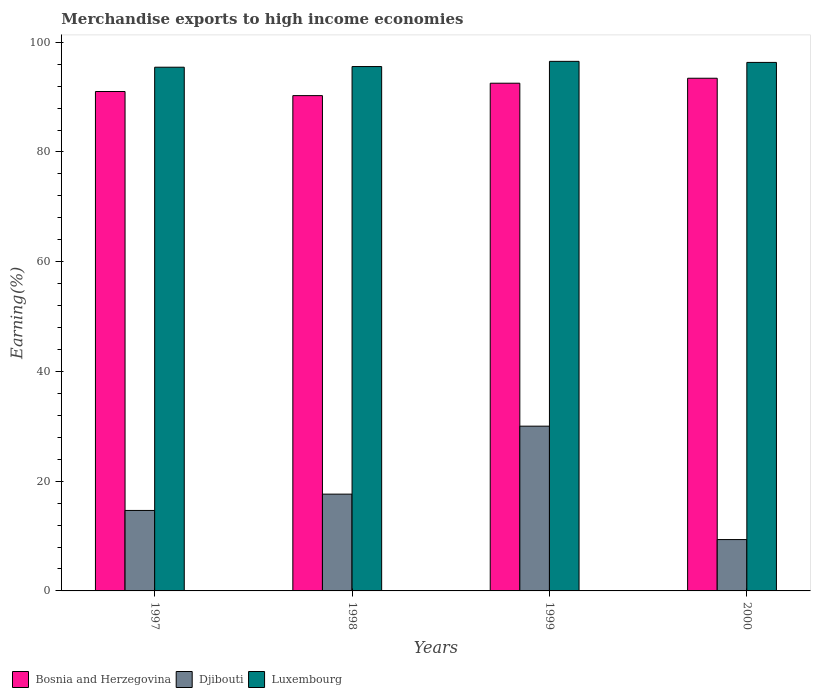How many different coloured bars are there?
Provide a short and direct response. 3. How many groups of bars are there?
Your answer should be very brief. 4. How many bars are there on the 3rd tick from the right?
Provide a succinct answer. 3. What is the label of the 3rd group of bars from the left?
Provide a short and direct response. 1999. What is the percentage of amount earned from merchandise exports in Bosnia and Herzegovina in 2000?
Keep it short and to the point. 93.43. Across all years, what is the maximum percentage of amount earned from merchandise exports in Djibouti?
Provide a succinct answer. 30.03. Across all years, what is the minimum percentage of amount earned from merchandise exports in Bosnia and Herzegovina?
Your response must be concise. 90.27. In which year was the percentage of amount earned from merchandise exports in Bosnia and Herzegovina minimum?
Keep it short and to the point. 1998. What is the total percentage of amount earned from merchandise exports in Bosnia and Herzegovina in the graph?
Ensure brevity in your answer.  367.25. What is the difference between the percentage of amount earned from merchandise exports in Bosnia and Herzegovina in 1999 and that in 2000?
Provide a succinct answer. -0.9. What is the difference between the percentage of amount earned from merchandise exports in Bosnia and Herzegovina in 1998 and the percentage of amount earned from merchandise exports in Luxembourg in 1999?
Keep it short and to the point. -6.25. What is the average percentage of amount earned from merchandise exports in Luxembourg per year?
Keep it short and to the point. 95.96. In the year 1998, what is the difference between the percentage of amount earned from merchandise exports in Bosnia and Herzegovina and percentage of amount earned from merchandise exports in Djibouti?
Your response must be concise. 72.63. In how many years, is the percentage of amount earned from merchandise exports in Bosnia and Herzegovina greater than 84 %?
Offer a very short reply. 4. What is the ratio of the percentage of amount earned from merchandise exports in Luxembourg in 1997 to that in 1998?
Your response must be concise. 1. What is the difference between the highest and the second highest percentage of amount earned from merchandise exports in Djibouti?
Your answer should be compact. 12.39. What is the difference between the highest and the lowest percentage of amount earned from merchandise exports in Luxembourg?
Make the answer very short. 1.07. What does the 1st bar from the left in 2000 represents?
Offer a very short reply. Bosnia and Herzegovina. What does the 1st bar from the right in 2000 represents?
Your answer should be very brief. Luxembourg. Are all the bars in the graph horizontal?
Ensure brevity in your answer.  No. Are the values on the major ticks of Y-axis written in scientific E-notation?
Provide a succinct answer. No. How many legend labels are there?
Your response must be concise. 3. How are the legend labels stacked?
Your response must be concise. Horizontal. What is the title of the graph?
Make the answer very short. Merchandise exports to high income economies. What is the label or title of the X-axis?
Give a very brief answer. Years. What is the label or title of the Y-axis?
Provide a short and direct response. Earning(%). What is the Earning(%) in Bosnia and Herzegovina in 1997?
Offer a very short reply. 91.02. What is the Earning(%) in Djibouti in 1997?
Give a very brief answer. 14.67. What is the Earning(%) in Luxembourg in 1997?
Give a very brief answer. 95.44. What is the Earning(%) in Bosnia and Herzegovina in 1998?
Provide a short and direct response. 90.27. What is the Earning(%) of Djibouti in 1998?
Your answer should be compact. 17.64. What is the Earning(%) of Luxembourg in 1998?
Keep it short and to the point. 95.57. What is the Earning(%) of Bosnia and Herzegovina in 1999?
Your response must be concise. 92.53. What is the Earning(%) of Djibouti in 1999?
Keep it short and to the point. 30.03. What is the Earning(%) in Luxembourg in 1999?
Your answer should be compact. 96.51. What is the Earning(%) of Bosnia and Herzegovina in 2000?
Offer a terse response. 93.43. What is the Earning(%) of Djibouti in 2000?
Provide a succinct answer. 9.36. What is the Earning(%) of Luxembourg in 2000?
Provide a short and direct response. 96.32. Across all years, what is the maximum Earning(%) in Bosnia and Herzegovina?
Your answer should be compact. 93.43. Across all years, what is the maximum Earning(%) in Djibouti?
Offer a very short reply. 30.03. Across all years, what is the maximum Earning(%) of Luxembourg?
Your answer should be compact. 96.51. Across all years, what is the minimum Earning(%) in Bosnia and Herzegovina?
Make the answer very short. 90.27. Across all years, what is the minimum Earning(%) in Djibouti?
Offer a terse response. 9.36. Across all years, what is the minimum Earning(%) of Luxembourg?
Ensure brevity in your answer.  95.44. What is the total Earning(%) in Bosnia and Herzegovina in the graph?
Provide a succinct answer. 367.25. What is the total Earning(%) in Djibouti in the graph?
Offer a terse response. 71.69. What is the total Earning(%) in Luxembourg in the graph?
Make the answer very short. 383.84. What is the difference between the Earning(%) of Bosnia and Herzegovina in 1997 and that in 1998?
Make the answer very short. 0.75. What is the difference between the Earning(%) of Djibouti in 1997 and that in 1998?
Provide a succinct answer. -2.97. What is the difference between the Earning(%) of Luxembourg in 1997 and that in 1998?
Ensure brevity in your answer.  -0.12. What is the difference between the Earning(%) of Bosnia and Herzegovina in 1997 and that in 1999?
Offer a terse response. -1.51. What is the difference between the Earning(%) of Djibouti in 1997 and that in 1999?
Your answer should be very brief. -15.36. What is the difference between the Earning(%) of Luxembourg in 1997 and that in 1999?
Offer a terse response. -1.07. What is the difference between the Earning(%) in Bosnia and Herzegovina in 1997 and that in 2000?
Provide a succinct answer. -2.42. What is the difference between the Earning(%) of Djibouti in 1997 and that in 2000?
Your answer should be compact. 5.31. What is the difference between the Earning(%) in Luxembourg in 1997 and that in 2000?
Your response must be concise. -0.87. What is the difference between the Earning(%) of Bosnia and Herzegovina in 1998 and that in 1999?
Provide a short and direct response. -2.26. What is the difference between the Earning(%) of Djibouti in 1998 and that in 1999?
Give a very brief answer. -12.39. What is the difference between the Earning(%) in Luxembourg in 1998 and that in 1999?
Your answer should be compact. -0.95. What is the difference between the Earning(%) of Bosnia and Herzegovina in 1998 and that in 2000?
Provide a succinct answer. -3.17. What is the difference between the Earning(%) of Djibouti in 1998 and that in 2000?
Provide a succinct answer. 8.28. What is the difference between the Earning(%) of Luxembourg in 1998 and that in 2000?
Make the answer very short. -0.75. What is the difference between the Earning(%) in Bosnia and Herzegovina in 1999 and that in 2000?
Keep it short and to the point. -0.9. What is the difference between the Earning(%) in Djibouti in 1999 and that in 2000?
Ensure brevity in your answer.  20.67. What is the difference between the Earning(%) in Luxembourg in 1999 and that in 2000?
Your answer should be very brief. 0.19. What is the difference between the Earning(%) of Bosnia and Herzegovina in 1997 and the Earning(%) of Djibouti in 1998?
Make the answer very short. 73.38. What is the difference between the Earning(%) in Bosnia and Herzegovina in 1997 and the Earning(%) in Luxembourg in 1998?
Give a very brief answer. -4.55. What is the difference between the Earning(%) of Djibouti in 1997 and the Earning(%) of Luxembourg in 1998?
Provide a short and direct response. -80.9. What is the difference between the Earning(%) in Bosnia and Herzegovina in 1997 and the Earning(%) in Djibouti in 1999?
Provide a succinct answer. 60.99. What is the difference between the Earning(%) in Bosnia and Herzegovina in 1997 and the Earning(%) in Luxembourg in 1999?
Provide a succinct answer. -5.5. What is the difference between the Earning(%) in Djibouti in 1997 and the Earning(%) in Luxembourg in 1999?
Your response must be concise. -81.85. What is the difference between the Earning(%) in Bosnia and Herzegovina in 1997 and the Earning(%) in Djibouti in 2000?
Your response must be concise. 81.66. What is the difference between the Earning(%) of Bosnia and Herzegovina in 1997 and the Earning(%) of Luxembourg in 2000?
Offer a terse response. -5.3. What is the difference between the Earning(%) in Djibouti in 1997 and the Earning(%) in Luxembourg in 2000?
Make the answer very short. -81.65. What is the difference between the Earning(%) of Bosnia and Herzegovina in 1998 and the Earning(%) of Djibouti in 1999?
Provide a short and direct response. 60.24. What is the difference between the Earning(%) of Bosnia and Herzegovina in 1998 and the Earning(%) of Luxembourg in 1999?
Your answer should be compact. -6.25. What is the difference between the Earning(%) in Djibouti in 1998 and the Earning(%) in Luxembourg in 1999?
Provide a succinct answer. -78.87. What is the difference between the Earning(%) in Bosnia and Herzegovina in 1998 and the Earning(%) in Djibouti in 2000?
Give a very brief answer. 80.91. What is the difference between the Earning(%) of Bosnia and Herzegovina in 1998 and the Earning(%) of Luxembourg in 2000?
Offer a terse response. -6.05. What is the difference between the Earning(%) of Djibouti in 1998 and the Earning(%) of Luxembourg in 2000?
Your response must be concise. -78.68. What is the difference between the Earning(%) in Bosnia and Herzegovina in 1999 and the Earning(%) in Djibouti in 2000?
Make the answer very short. 83.17. What is the difference between the Earning(%) of Bosnia and Herzegovina in 1999 and the Earning(%) of Luxembourg in 2000?
Give a very brief answer. -3.79. What is the difference between the Earning(%) of Djibouti in 1999 and the Earning(%) of Luxembourg in 2000?
Provide a succinct answer. -66.29. What is the average Earning(%) in Bosnia and Herzegovina per year?
Your response must be concise. 91.81. What is the average Earning(%) in Djibouti per year?
Your answer should be compact. 17.92. What is the average Earning(%) in Luxembourg per year?
Provide a succinct answer. 95.96. In the year 1997, what is the difference between the Earning(%) in Bosnia and Herzegovina and Earning(%) in Djibouti?
Offer a terse response. 76.35. In the year 1997, what is the difference between the Earning(%) of Bosnia and Herzegovina and Earning(%) of Luxembourg?
Ensure brevity in your answer.  -4.43. In the year 1997, what is the difference between the Earning(%) in Djibouti and Earning(%) in Luxembourg?
Keep it short and to the point. -80.78. In the year 1998, what is the difference between the Earning(%) of Bosnia and Herzegovina and Earning(%) of Djibouti?
Provide a short and direct response. 72.63. In the year 1998, what is the difference between the Earning(%) in Bosnia and Herzegovina and Earning(%) in Luxembourg?
Offer a very short reply. -5.3. In the year 1998, what is the difference between the Earning(%) of Djibouti and Earning(%) of Luxembourg?
Offer a terse response. -77.93. In the year 1999, what is the difference between the Earning(%) in Bosnia and Herzegovina and Earning(%) in Djibouti?
Offer a very short reply. 62.5. In the year 1999, what is the difference between the Earning(%) in Bosnia and Herzegovina and Earning(%) in Luxembourg?
Make the answer very short. -3.98. In the year 1999, what is the difference between the Earning(%) in Djibouti and Earning(%) in Luxembourg?
Provide a succinct answer. -66.49. In the year 2000, what is the difference between the Earning(%) of Bosnia and Herzegovina and Earning(%) of Djibouti?
Provide a short and direct response. 84.08. In the year 2000, what is the difference between the Earning(%) of Bosnia and Herzegovina and Earning(%) of Luxembourg?
Your answer should be very brief. -2.88. In the year 2000, what is the difference between the Earning(%) of Djibouti and Earning(%) of Luxembourg?
Your answer should be compact. -86.96. What is the ratio of the Earning(%) in Bosnia and Herzegovina in 1997 to that in 1998?
Give a very brief answer. 1.01. What is the ratio of the Earning(%) in Djibouti in 1997 to that in 1998?
Ensure brevity in your answer.  0.83. What is the ratio of the Earning(%) of Bosnia and Herzegovina in 1997 to that in 1999?
Offer a very short reply. 0.98. What is the ratio of the Earning(%) of Djibouti in 1997 to that in 1999?
Give a very brief answer. 0.49. What is the ratio of the Earning(%) in Luxembourg in 1997 to that in 1999?
Your response must be concise. 0.99. What is the ratio of the Earning(%) of Bosnia and Herzegovina in 1997 to that in 2000?
Provide a short and direct response. 0.97. What is the ratio of the Earning(%) in Djibouti in 1997 to that in 2000?
Ensure brevity in your answer.  1.57. What is the ratio of the Earning(%) of Luxembourg in 1997 to that in 2000?
Give a very brief answer. 0.99. What is the ratio of the Earning(%) in Bosnia and Herzegovina in 1998 to that in 1999?
Offer a terse response. 0.98. What is the ratio of the Earning(%) of Djibouti in 1998 to that in 1999?
Give a very brief answer. 0.59. What is the ratio of the Earning(%) in Luxembourg in 1998 to that in 1999?
Provide a succinct answer. 0.99. What is the ratio of the Earning(%) of Bosnia and Herzegovina in 1998 to that in 2000?
Offer a very short reply. 0.97. What is the ratio of the Earning(%) in Djibouti in 1998 to that in 2000?
Offer a terse response. 1.89. What is the ratio of the Earning(%) of Bosnia and Herzegovina in 1999 to that in 2000?
Offer a very short reply. 0.99. What is the ratio of the Earning(%) in Djibouti in 1999 to that in 2000?
Offer a terse response. 3.21. What is the difference between the highest and the second highest Earning(%) in Bosnia and Herzegovina?
Make the answer very short. 0.9. What is the difference between the highest and the second highest Earning(%) of Djibouti?
Provide a succinct answer. 12.39. What is the difference between the highest and the second highest Earning(%) of Luxembourg?
Your answer should be compact. 0.19. What is the difference between the highest and the lowest Earning(%) of Bosnia and Herzegovina?
Provide a succinct answer. 3.17. What is the difference between the highest and the lowest Earning(%) in Djibouti?
Your answer should be compact. 20.67. What is the difference between the highest and the lowest Earning(%) in Luxembourg?
Make the answer very short. 1.07. 